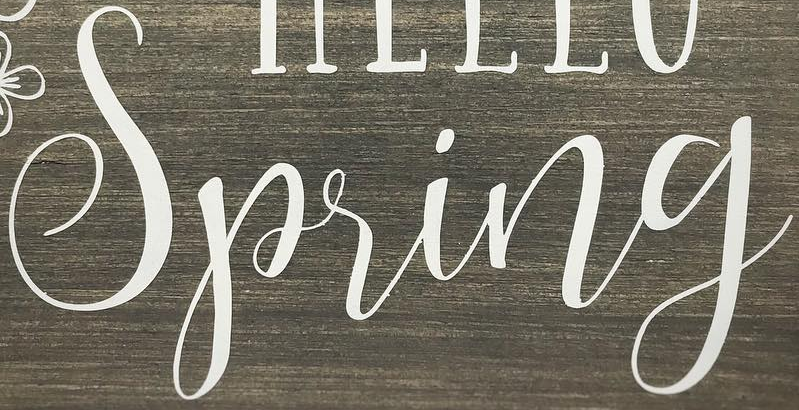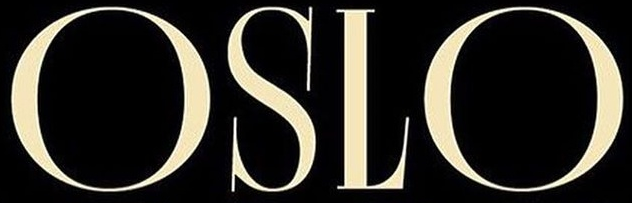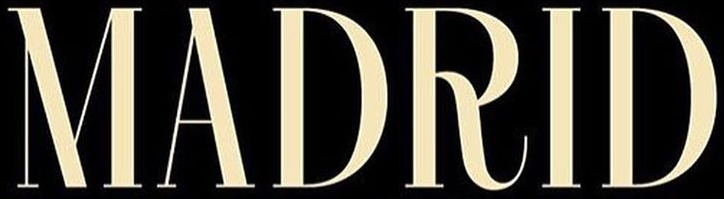Identify the words shown in these images in order, separated by a semicolon. Spring; OSLO; MADRID 